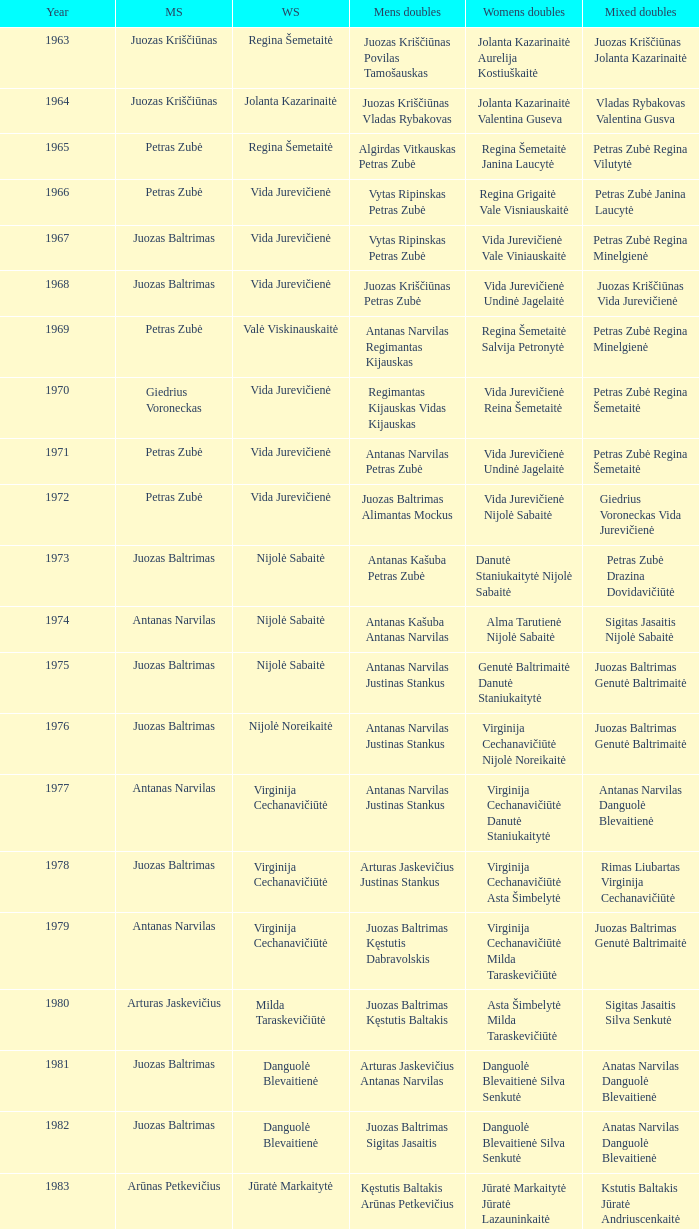What was the first year of the Lithuanian National Badminton Championships? 1963.0. 